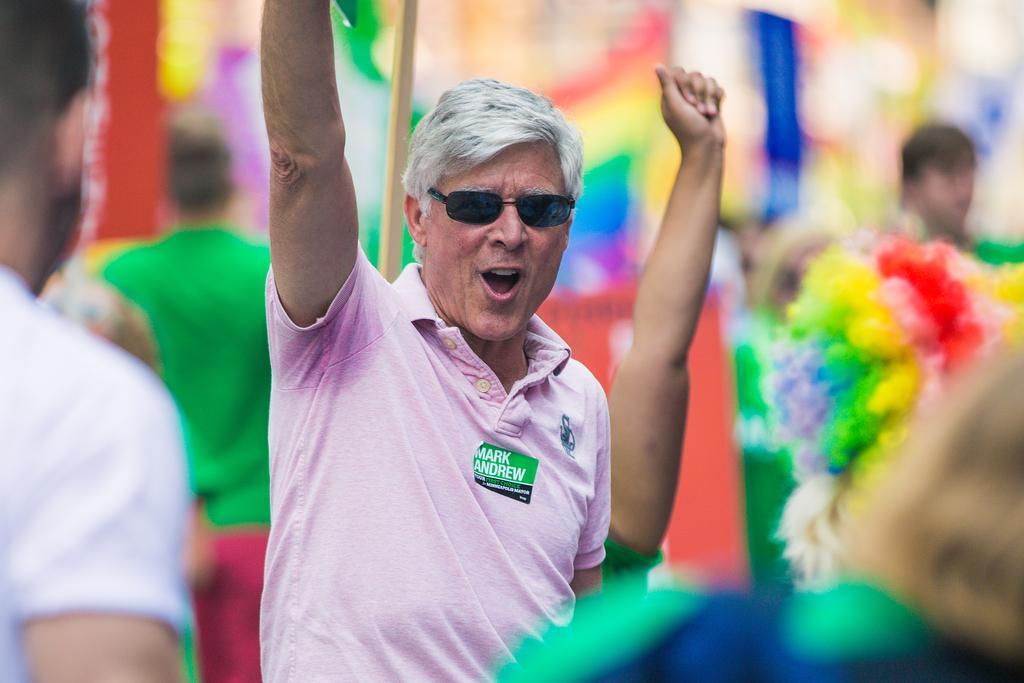Can you describe this image briefly? This picture describes about group of people, in the middle of the image we can see a man, he wore spectacles and we can see blurry background. 